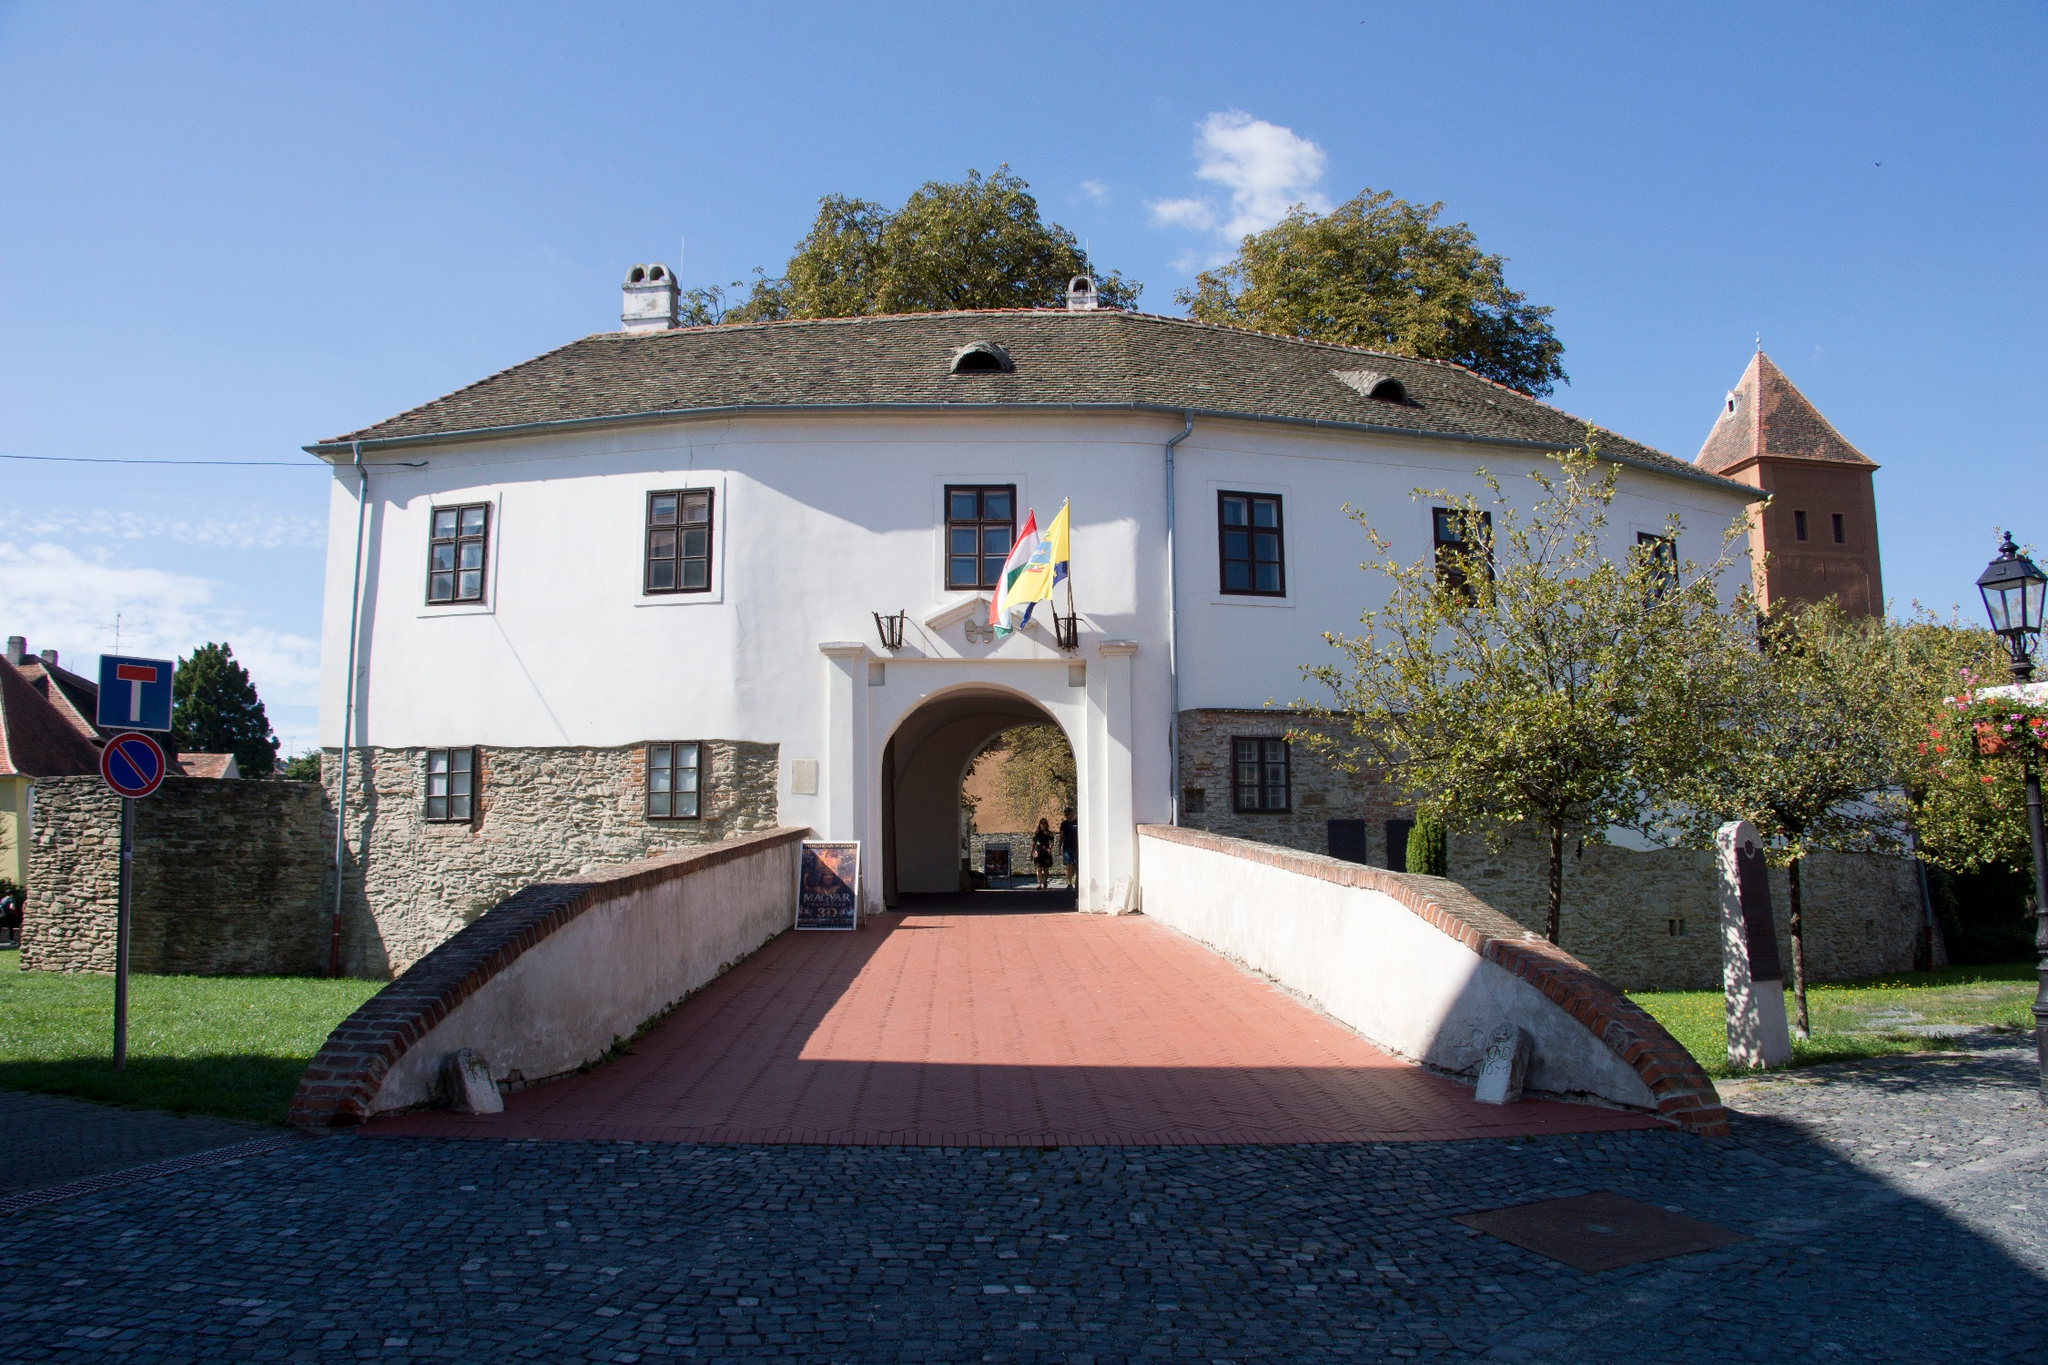Describe the historical significance of this location. The image captures the entrance to the Prejmer fortified church in Romania, a site of profound historical significance. Established by the Teutonic Knights in the early 13th century, this church is one of the best-preserved fortified churches in Eastern Europe. Its robust defensive walls and strategic design reflect the tumultuous history of the region, marked by frequent invasions and conflicts. This architectural marvel served not only as a place of worship but also as a sanctuary for the local population during times of siege. The red-tiled roof, stone fortifications, and overall structural integrity speak volumes about the medieval craftsmanship and the socio-political importance of such fortifications in safeguarding communities of that era. What architectural features stand out in this church? The architectural features of the Prejmer fortified church that stand out include its massive, thick stone walls designed for defense, a hallmark of medieval fortifications. The building's white facade, juxtaposed with its red-tiled roof, creates a striking visual appeal. Additionally, the presence of a small watchtower suggests the need for continuous vigilance and protection. The red brick walkway leading up to the entrance adds a welcoming touch to the otherwise robust and imposing structure. On closer inspection, the symmetry of the windows and the detailed masonry exhibit the finesse of medieval construction techniques, while the overall layout underscores the dual function of the complex as both a religious sanctuary and a defensive bastion. 